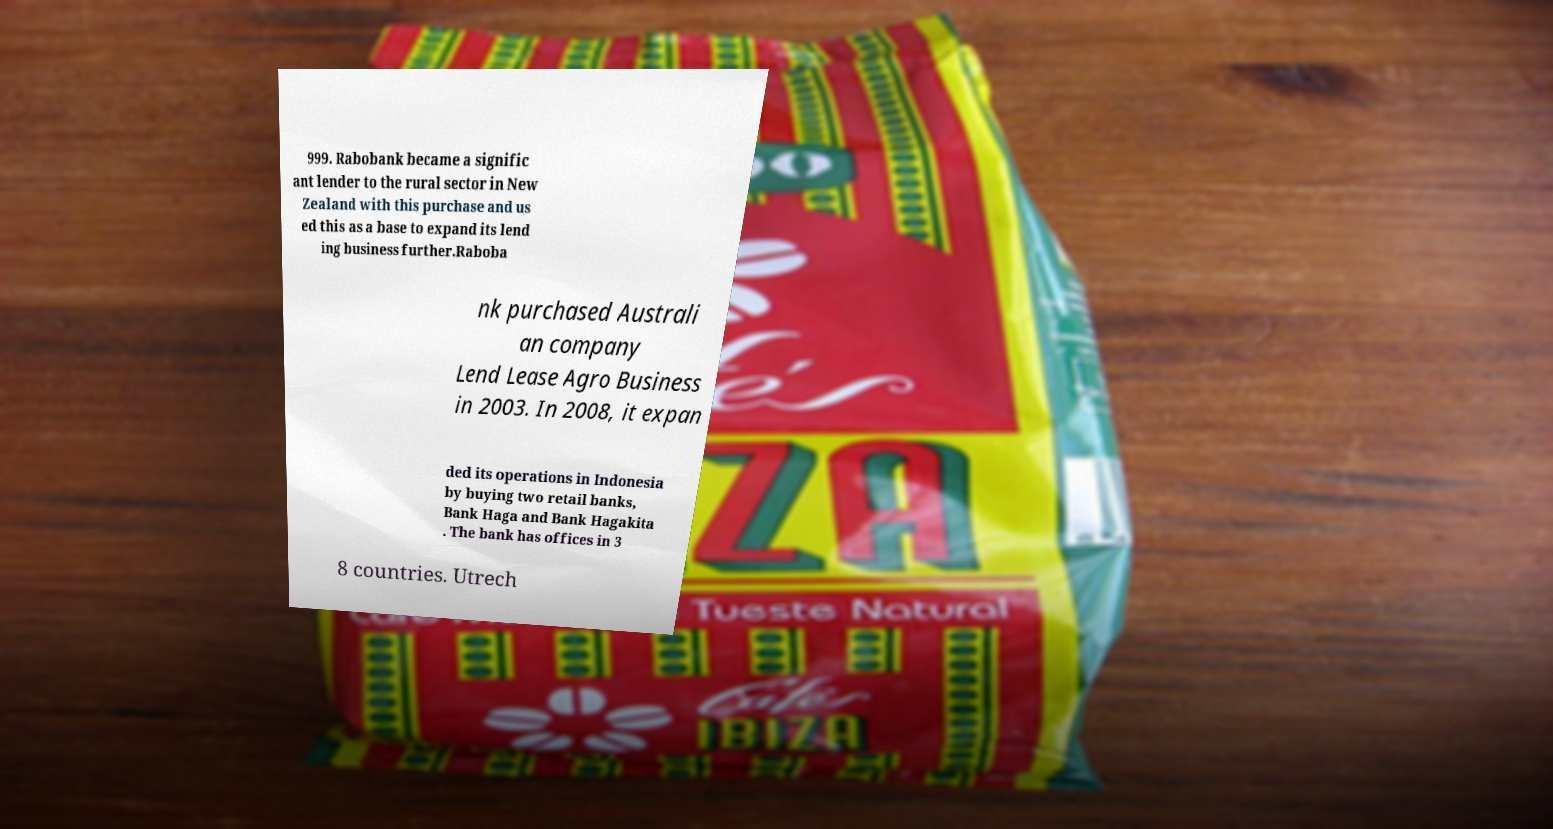Please read and relay the text visible in this image. What does it say? 999. Rabobank became a signific ant lender to the rural sector in New Zealand with this purchase and us ed this as a base to expand its lend ing business further.Raboba nk purchased Australi an company Lend Lease Agro Business in 2003. In 2008, it expan ded its operations in Indonesia by buying two retail banks, Bank Haga and Bank Hagakita . The bank has offices in 3 8 countries. Utrech 